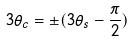Convert formula to latex. <formula><loc_0><loc_0><loc_500><loc_500>3 \theta _ { c } = \pm ( 3 \theta _ { s } - \frac { \pi } { 2 } )</formula> 